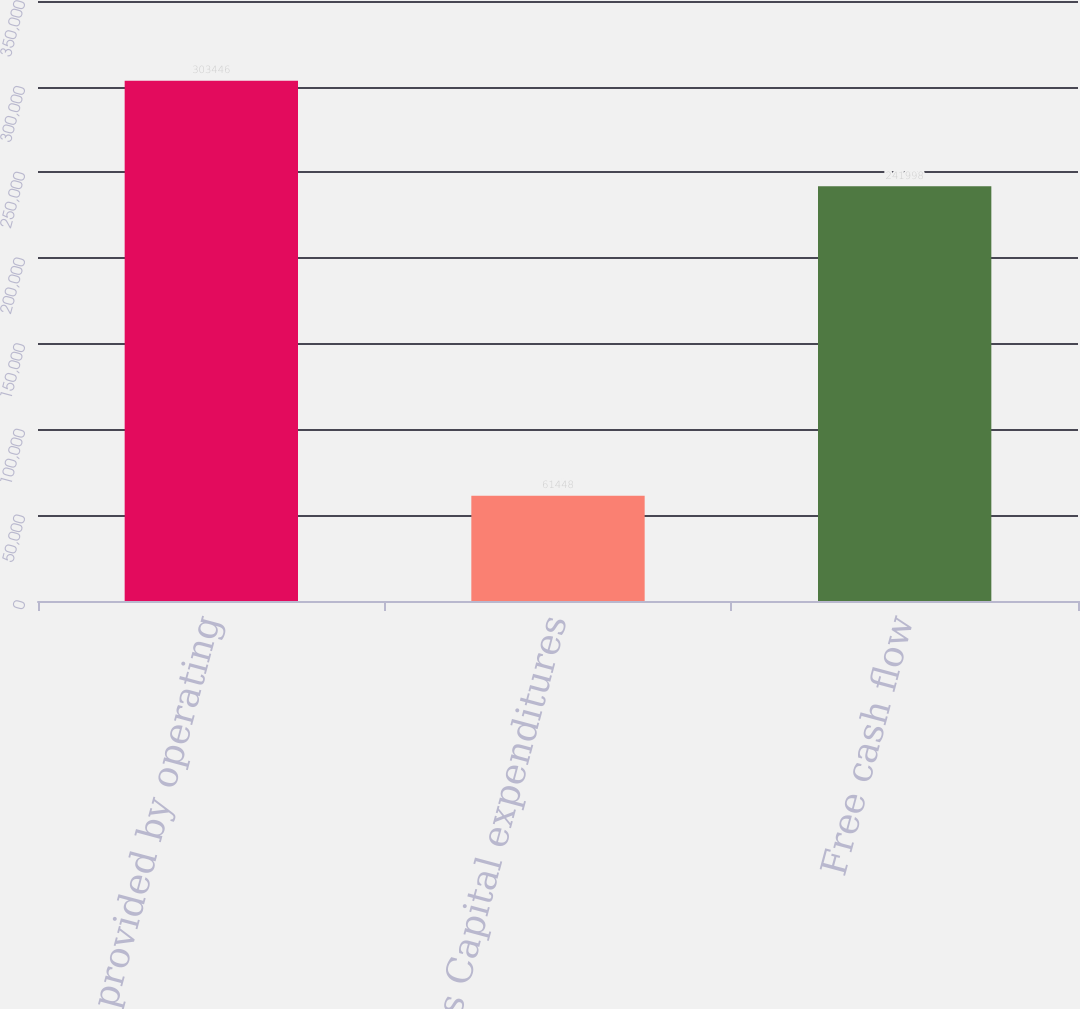Convert chart. <chart><loc_0><loc_0><loc_500><loc_500><bar_chart><fcel>Net cash provided by operating<fcel>Less Capital expenditures<fcel>Free cash flow<nl><fcel>303446<fcel>61448<fcel>241998<nl></chart> 